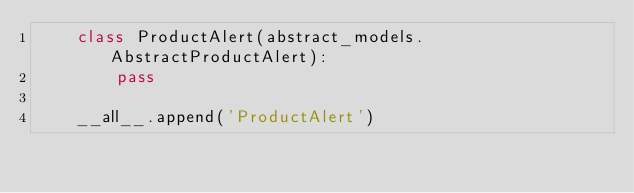Convert code to text. <code><loc_0><loc_0><loc_500><loc_500><_Python_>    class ProductAlert(abstract_models.AbstractProductAlert):
        pass

    __all__.append('ProductAlert')
</code> 